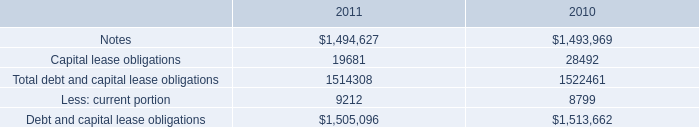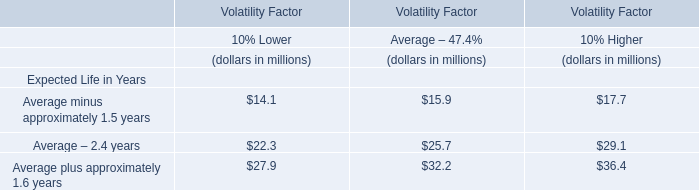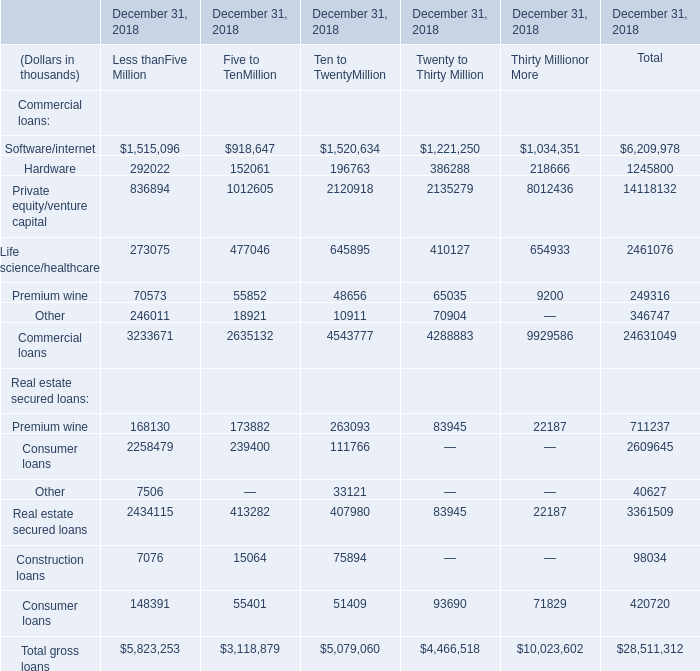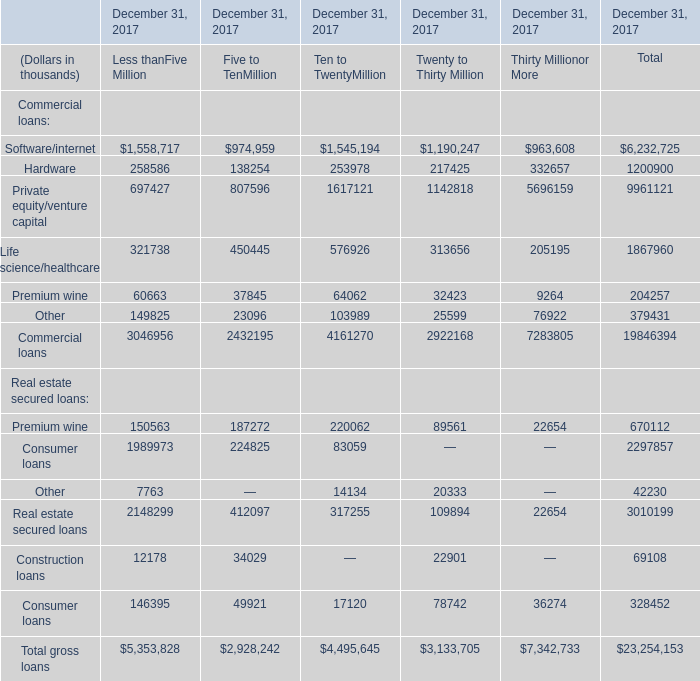What was the average value of the Other in the years for Commercial loans where Software/internet of Commercial loans is positive for Less thanFive Million for total? (in thousand) 
Computations: (379431 / 1)
Answer: 379431.0. 